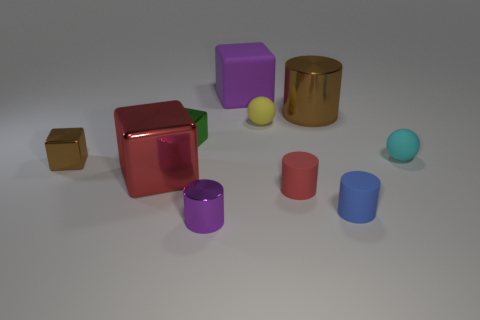Subtract all brown shiny cylinders. How many cylinders are left? 3 Subtract all blue cylinders. How many cylinders are left? 3 Subtract all cylinders. How many objects are left? 6 Subtract 2 blocks. How many blocks are left? 2 Subtract all green spheres. How many yellow cubes are left? 0 Subtract all purple shiny cylinders. Subtract all tiny red rubber things. How many objects are left? 8 Add 3 big cylinders. How many big cylinders are left? 4 Add 1 large brown cubes. How many large brown cubes exist? 1 Subtract 0 cyan cubes. How many objects are left? 10 Subtract all yellow blocks. Subtract all red cylinders. How many blocks are left? 4 